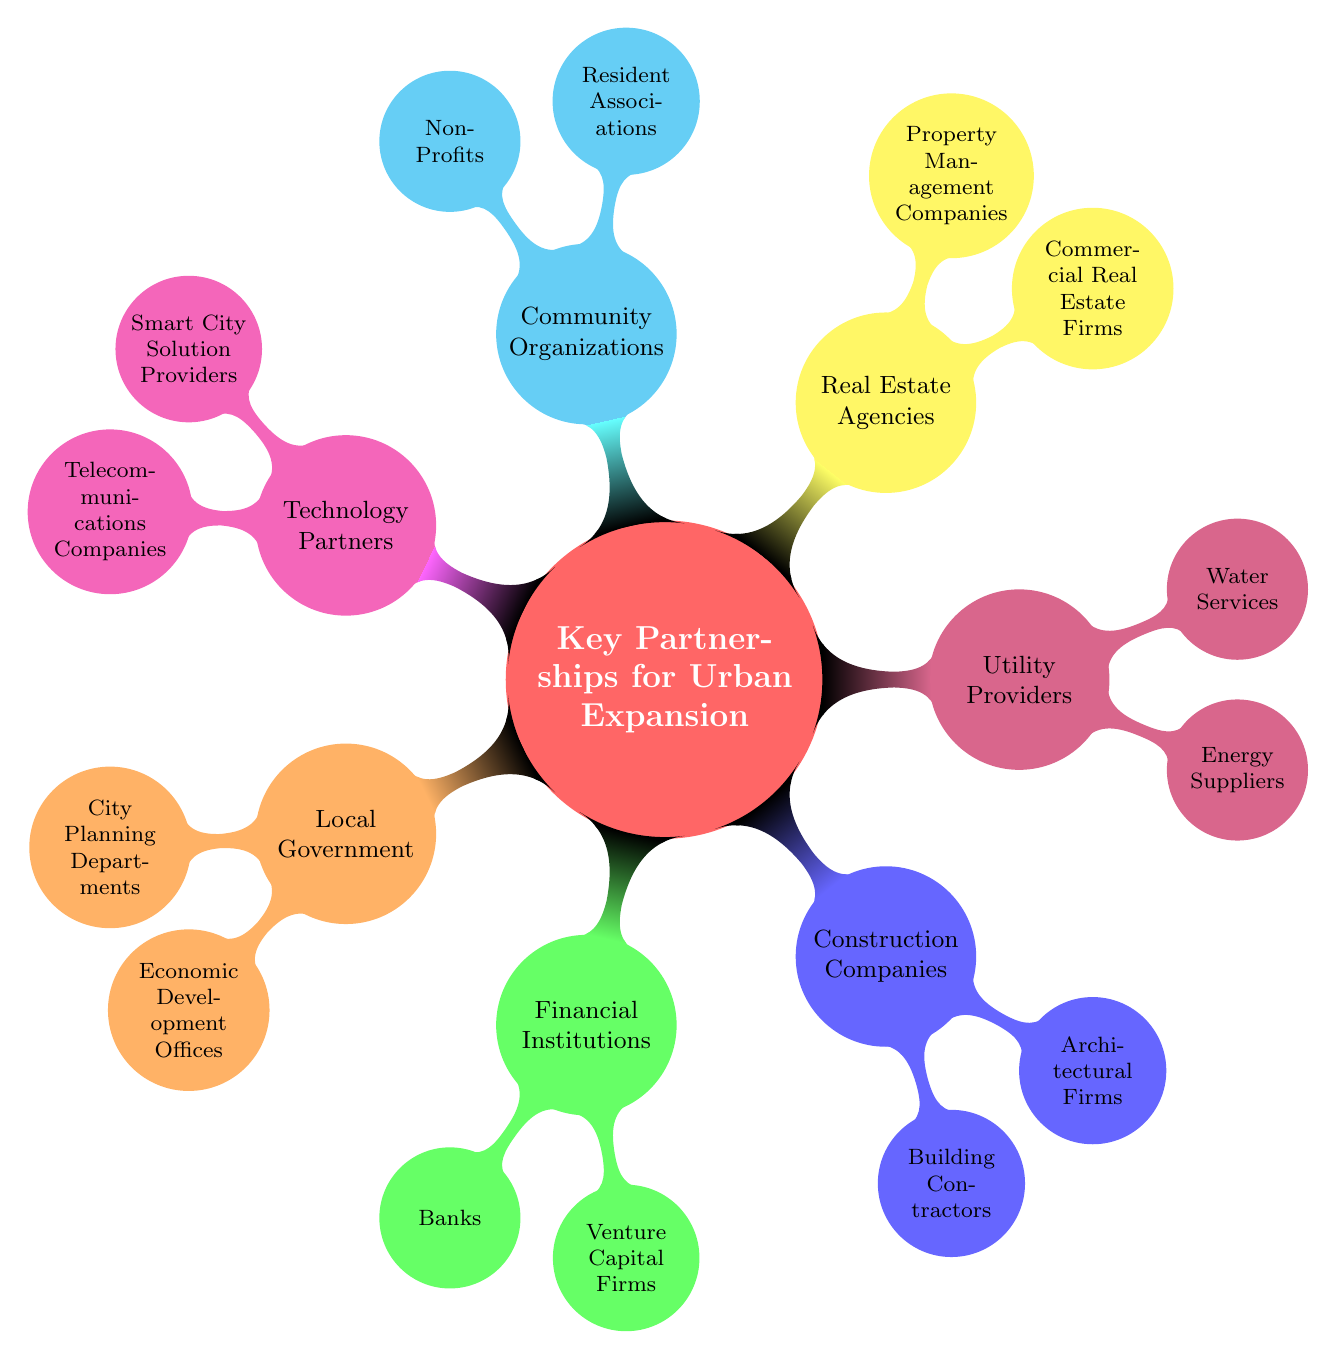What is the central theme of the mind map? The central theme is represented by the main node at the center, labeled "Key Partnerships for Urban Expansion." This describes the overall focus of the mind map.
Answer: Key Partnerships for Urban Expansion How many main partnership categories are listed? By counting the top-level nodes that branch out from the central theme, we find there are a total of 7 categories: Local Government, Financial Institutions, Construction Companies, Utility Providers, Real Estate Agencies, Community Organizations, and Technology Partners.
Answer: 7 Which category includes banks? The banks are listed under the category "Financial Institutions," which indicates their role in providing funding and financial services pertinent to urban expansion projects.
Answer: Financial Institutions What is one purpose of the Economic Development Offices? The purpose of Economic Development Offices is to seek incentives and grants for development projects, which is crucial for funding urban expansion initiatives.
Answer: Seek incentives and grants for development projects How many nodes are there under Community Organizations? There are 2 nodes under Community Organizations: Resident Associations and Non-Profits, which shows the specific types of partnerships that can be formed in this area.
Answer: 2 What is a common goal of the Utility Providers? Utility Providers, specifically mentioning Energy Suppliers and Water Services, commonly aim to collaborate on meeting energy needs and ensuring efficient water management for urban development.
Answer: Collaborate on energy needs and sustainable solutions Which node is responsible for tenant management? The node responsible for tenant management is "Property Management Companies," indicating their function in managing and maintaining properties after development.
Answer: Property Management Companies How are Smart City Solution Providers related to urban management? Smart City Solution Providers are included in the Technology Partners category and are aimed at incorporating advanced technologies, which means they significantly contribute to improving urban management through innovation.
Answer: Incorporate advanced technologies for urban management 